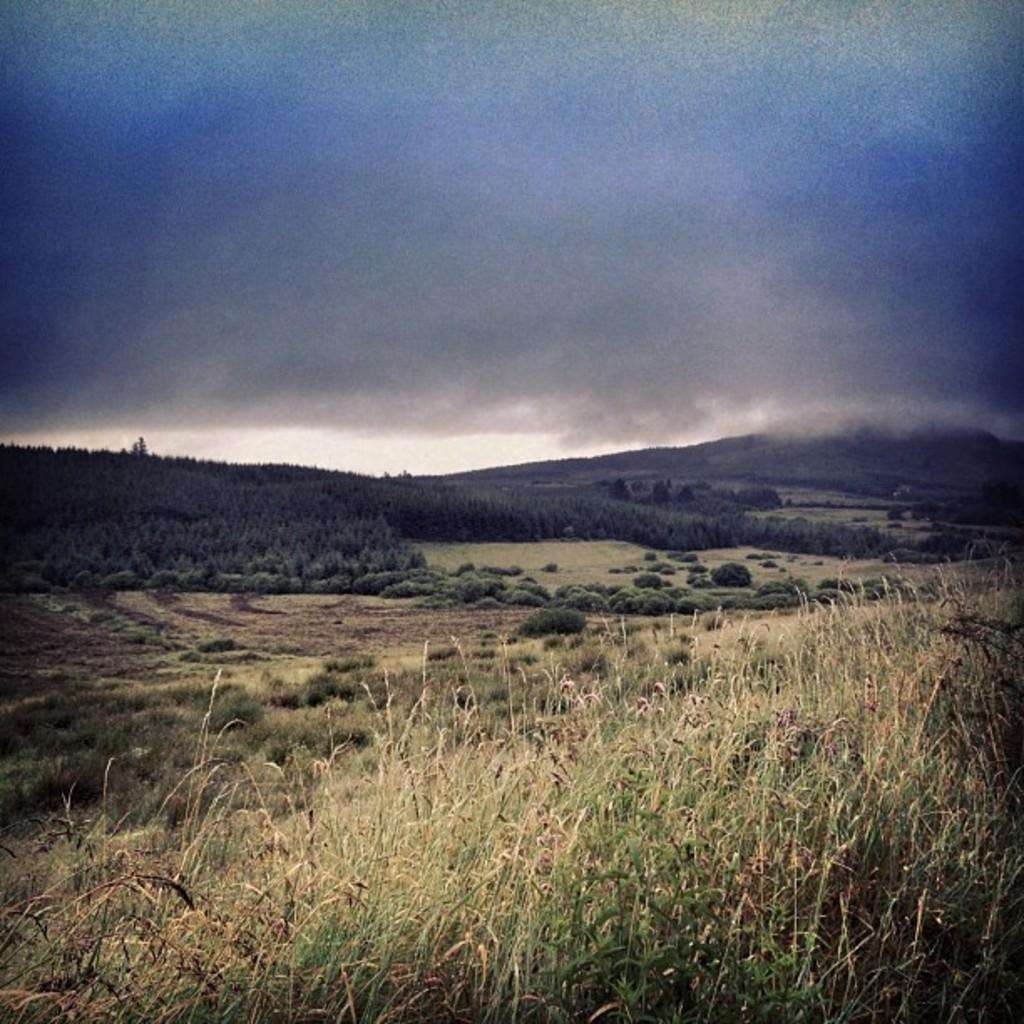What type of vegetation can be seen in the image? There is grass in the image. What other natural elements are present in the image? There are trees in the image. What can be seen in the sky in the image? There are clouds visible in the image. How many jars of jelly can be seen on the roof in the image? There is no roof or jelly present in the image. Are there any babies visible in the image? There are no babies present in the image. 